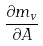<formula> <loc_0><loc_0><loc_500><loc_500>\frac { \partial m _ { v } } { \partial A }</formula> 